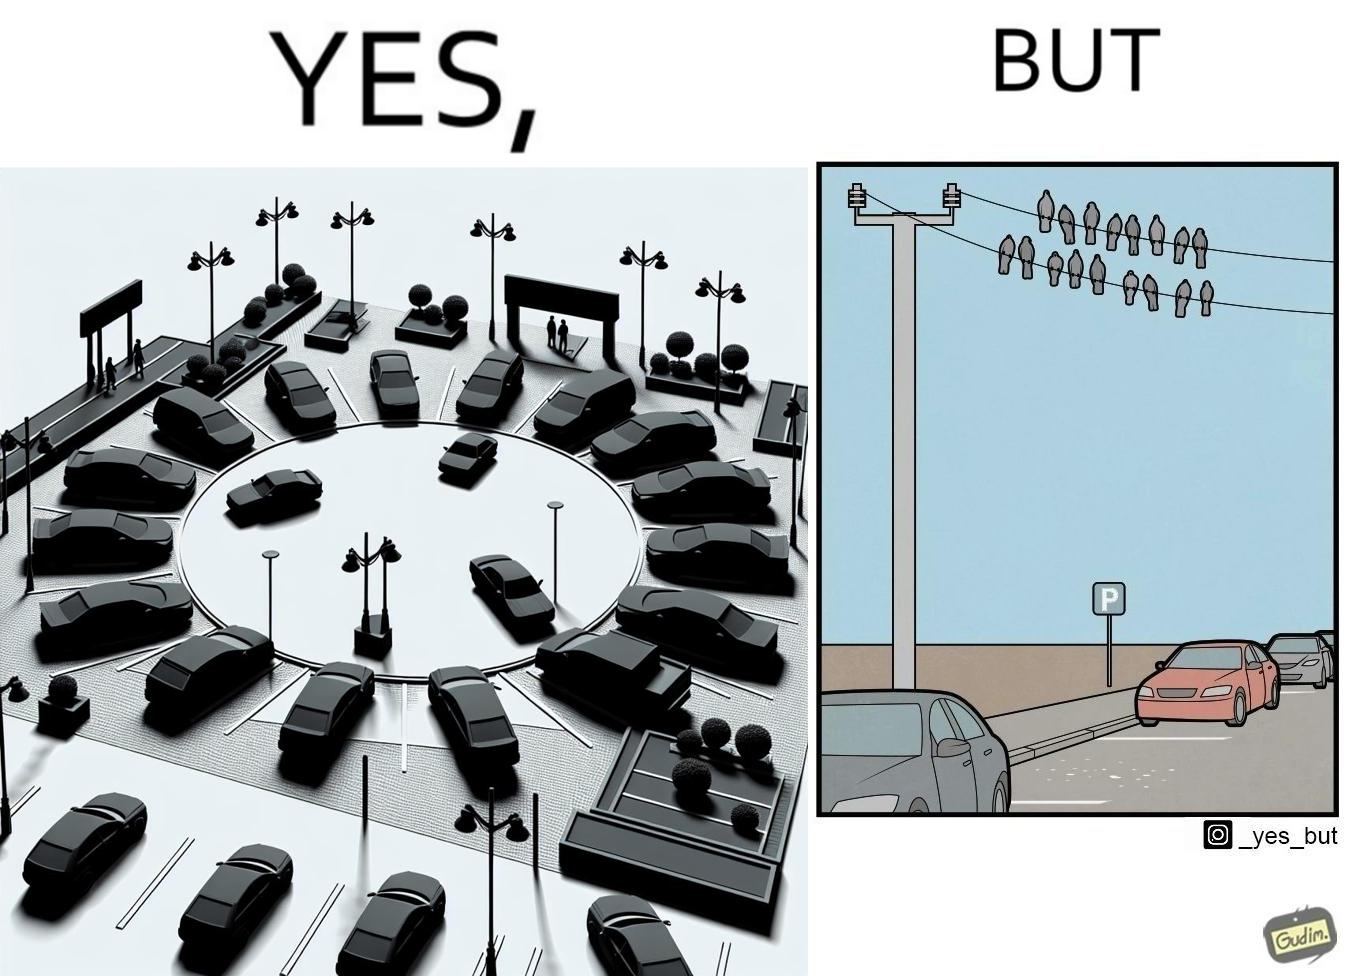Compare the left and right sides of this image. In the left part of the image: There is a parking place where few cars are standing leaving a place in middle. In the right part of the image: Some crows are sitting on a wire which is above the parking area and the crows are making that place dirty. 